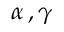Convert formula to latex. <formula><loc_0><loc_0><loc_500><loc_500>\alpha \, , \gamma</formula> 